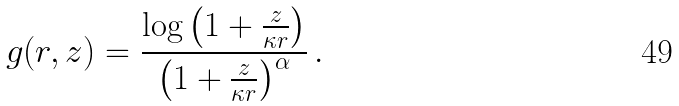<formula> <loc_0><loc_0><loc_500><loc_500>g ( r , z ) = \frac { \log \left ( 1 + \frac { z } { \kappa r } \right ) } { \left ( 1 + \frac { z } { \kappa r } \right ) ^ { \alpha } } \, .</formula> 